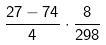<formula> <loc_0><loc_0><loc_500><loc_500>\frac { 2 7 - 7 4 } { 4 } \cdot \frac { 8 } { 2 9 8 }</formula> 